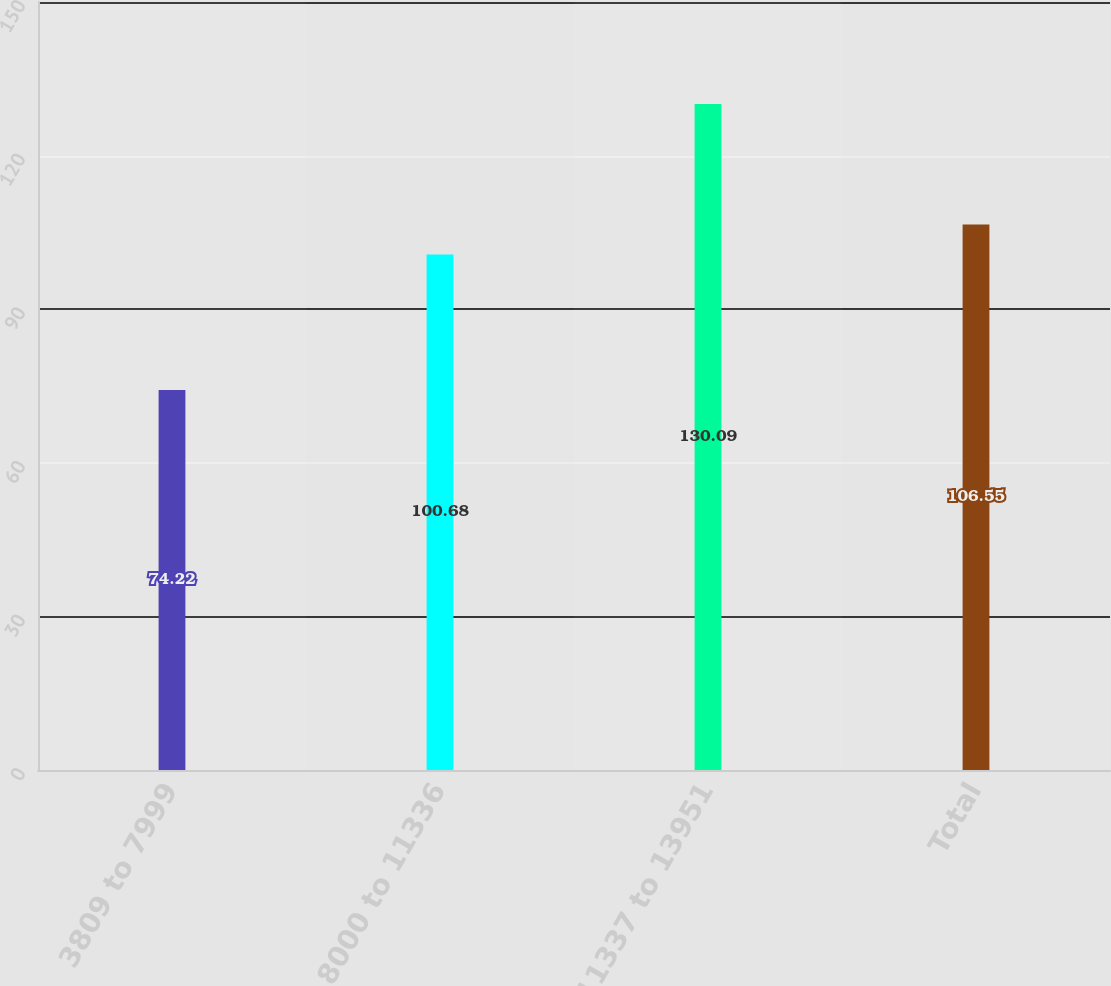Convert chart. <chart><loc_0><loc_0><loc_500><loc_500><bar_chart><fcel>3809 to 7999<fcel>8000 to 11336<fcel>11337 to 13951<fcel>Total<nl><fcel>74.22<fcel>100.68<fcel>130.09<fcel>106.55<nl></chart> 